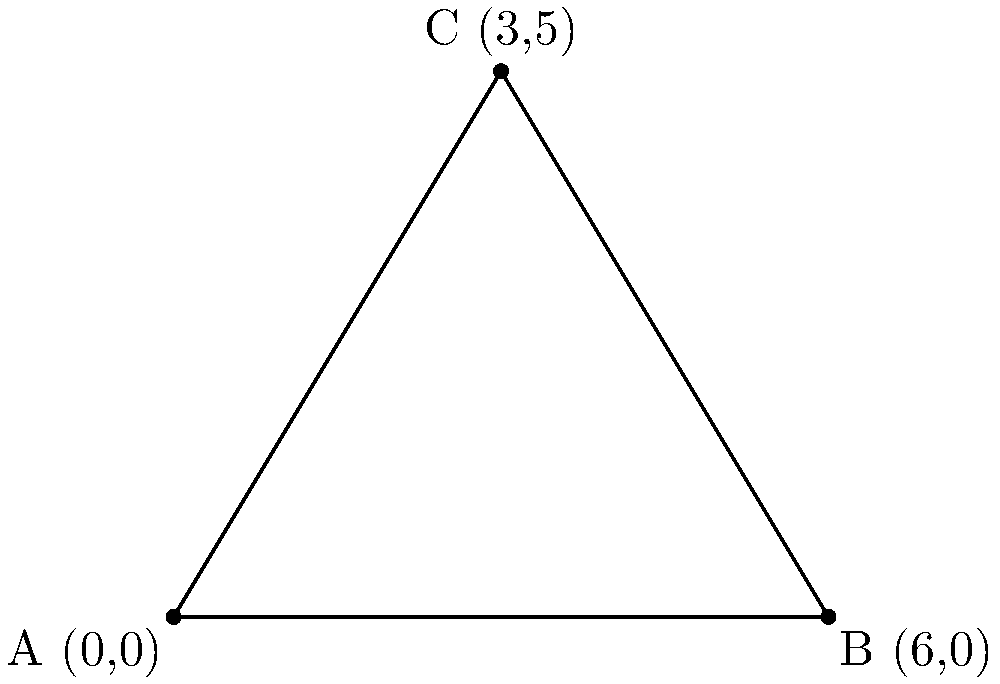In a client communication effectiveness model, three aspects are represented by coordinates on a graph: Client Satisfaction (x-axis), Communication Frequency (y-axis), and Responsiveness (z-axis, represented by the length of the base). The coordinates are A(0,0), B(6,0), and C(3,5). Calculate the area of the triangle formed by these points to determine the overall effectiveness of the communication strategy. To find the area of the triangle, we can use the formula:

Area = $\frac{1}{2}|x_1(y_2 - y_3) + x_2(y_3 - y_1) + x_3(y_1 - y_2)|$

Where $(x_1,y_1)$, $(x_2,y_2)$, and $(x_3,y_3)$ are the coordinates of the three points.

Step 1: Identify the coordinates
A(0,0), B(6,0), C(3,5)

Step 2: Plug the coordinates into the formula
Area = $\frac{1}{2}|0(0 - 5) + 6(5 - 0) + 3(0 - 0)|$

Step 3: Simplify
Area = $\frac{1}{2}|0 + 30 + 0|$
Area = $\frac{1}{2}(30)$

Step 4: Calculate the final result
Area = 15 square units

The area of 15 square units represents the overall effectiveness of the communication strategy, taking into account client satisfaction, communication frequency, and responsiveness.
Answer: 15 square units 